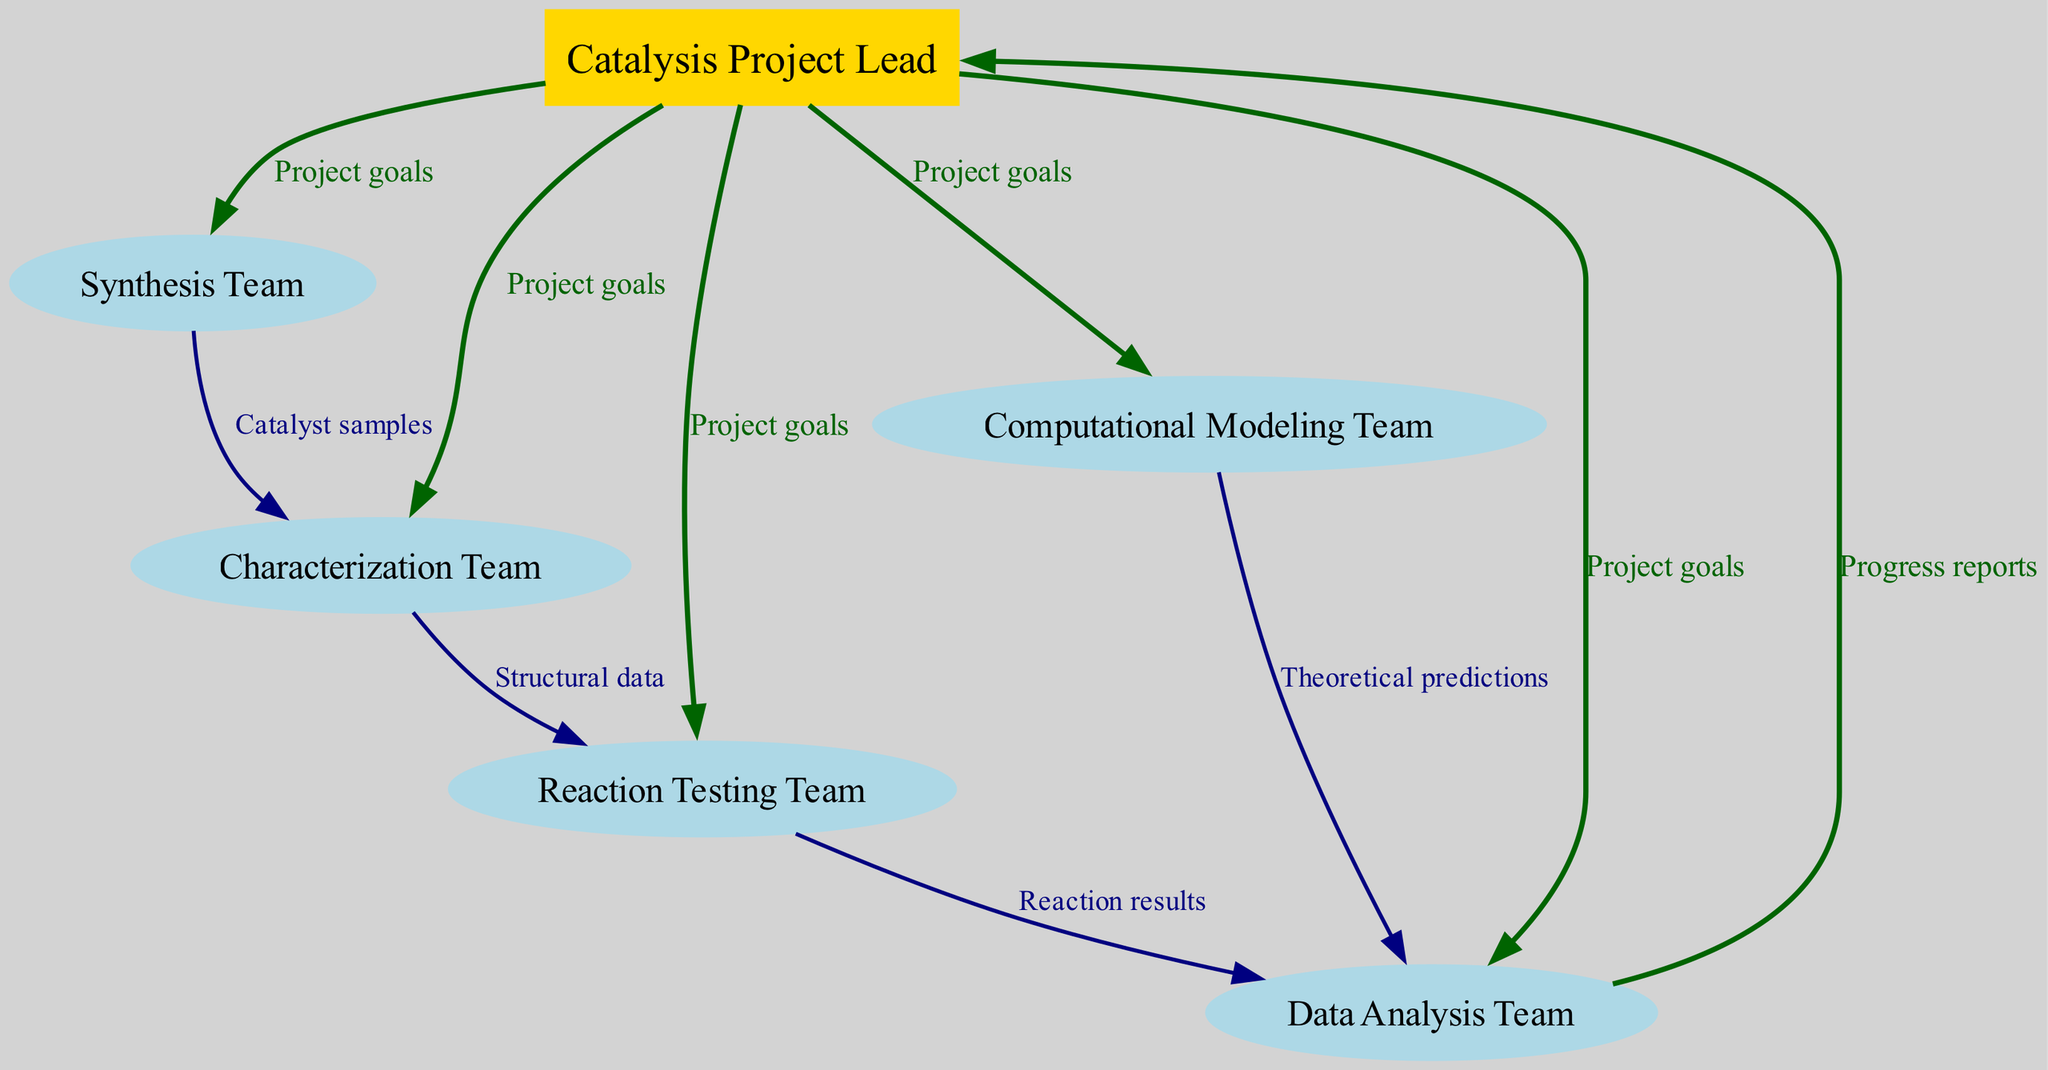What is the total number of nodes in the diagram? The diagram includes six distinct nodes: Catalysis Project Lead, Synthesis Team, Characterization Team, Reaction Testing Team, Computational Modeling Team, and Data Analysis Team. Thus, the total count is six.
Answer: 6 Which team directly receives catalyst samples from the Synthesis Team? Exploring the diagram, the Synthesis Team sends catalyst samples directly to the Characterization Team based on the represented edge. Therefore, the answer is the Characterization Team.
Answer: Characterization Team What type of information flows from the Reaction Testing Team to the Data Analysis Team? Looking at the diagram, the edge indicates that the Reaction Testing Team provides "Reaction results" to the Data Analysis Team. This information flow is specifically labeled.
Answer: Reaction results Who is responsible for theoretical predictions? Tracing the edges, the Computational Modeling Team provides "Theoretical predictions," as indicated by the direct edge leading to the Data Analysis Team. This identification leads to the answer being the Computational Modeling Team.
Answer: Computational Modeling Team How many teams are directly linked to the Catalysis Project Lead? The diagram shows that the Catalysis Project Lead is connected to five other teams, specifically the Synthesis Team, Characterization Team, Reaction Testing Team, Computational Modeling Team, and Data Analysis Team. Thus, the count of directly linked teams is five.
Answer: 5 Which team reports progress back to the Catalysis Project Lead? Following the flow in the diagram, the Data Analysis Team is the team that sends "Progress reports" back to the Catalysis Project Lead. This is seen through the connecting edge directed towards the Project Lead.
Answer: Data Analysis Team What is the label of the edge connecting the Characterization Team and the Reaction Testing Team? The diagram clearly states the connection as "Structural data" through the edge that connects the Characterization Team to the Reaction Testing Team. Thus, this label provides the answer.
Answer: Structural data Which team has the first interaction with the Catalysis Project Lead? According to the diagram, the first interaction with the Catalysis Project Lead involves setting "Project goals," as the Project Lead communicates this to all teams. The Synthesis Team is the first listed in the direct connections.
Answer: Synthesis Team What color represents the edges linking the teams to the Catalysis Project Lead? The edges that connect the different teams to the Catalysis Project Lead are colored dark green, signifying the nature of these connections as critical project goal communications.
Answer: Dark green 